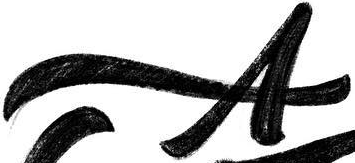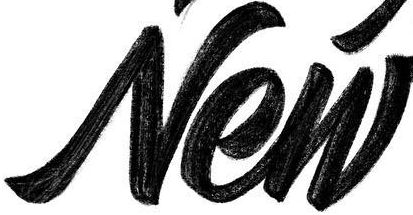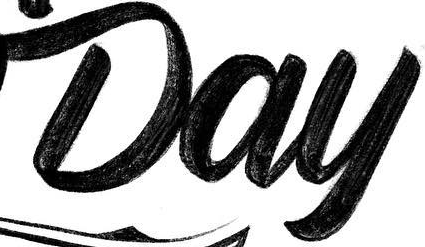Transcribe the words shown in these images in order, separated by a semicolon. A; New; Day 